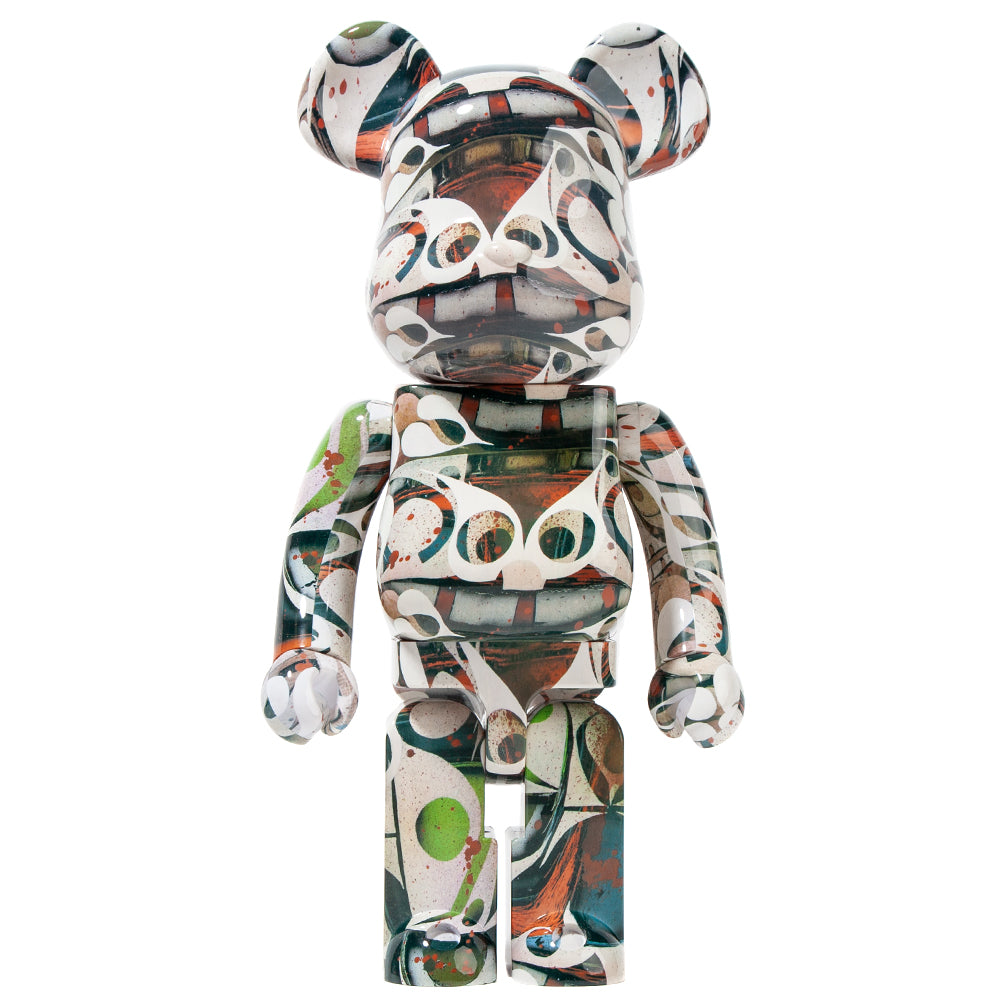If this figurine could tell a story, what might it say? If the figurine could tell a story, it might narrate a tale of boundless creativity and emotion. It could describe a journey through a world where colors and shapes interact in a dance of spontaneity and passion, expressing the unspoken and the unseen. The figurine might speak of the artist's internal struggles, dreams, and inspirations, showcasing each splash and stroke of paint as a reflection of moments of triumph, despair, and revelation. This story could be an exploration of how art can transcend the conventional, merging the familiar with the abstract to create a visual symphony that invites viewers to find their own narrative in its patterns. 